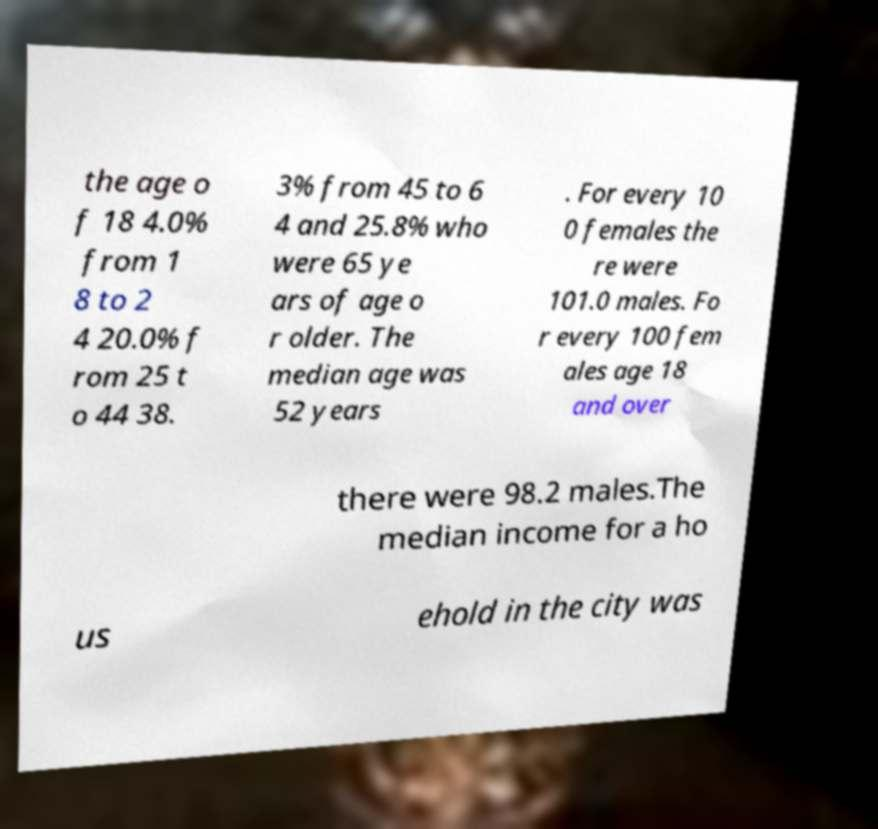Could you assist in decoding the text presented in this image and type it out clearly? the age o f 18 4.0% from 1 8 to 2 4 20.0% f rom 25 t o 44 38. 3% from 45 to 6 4 and 25.8% who were 65 ye ars of age o r older. The median age was 52 years . For every 10 0 females the re were 101.0 males. Fo r every 100 fem ales age 18 and over there were 98.2 males.The median income for a ho us ehold in the city was 